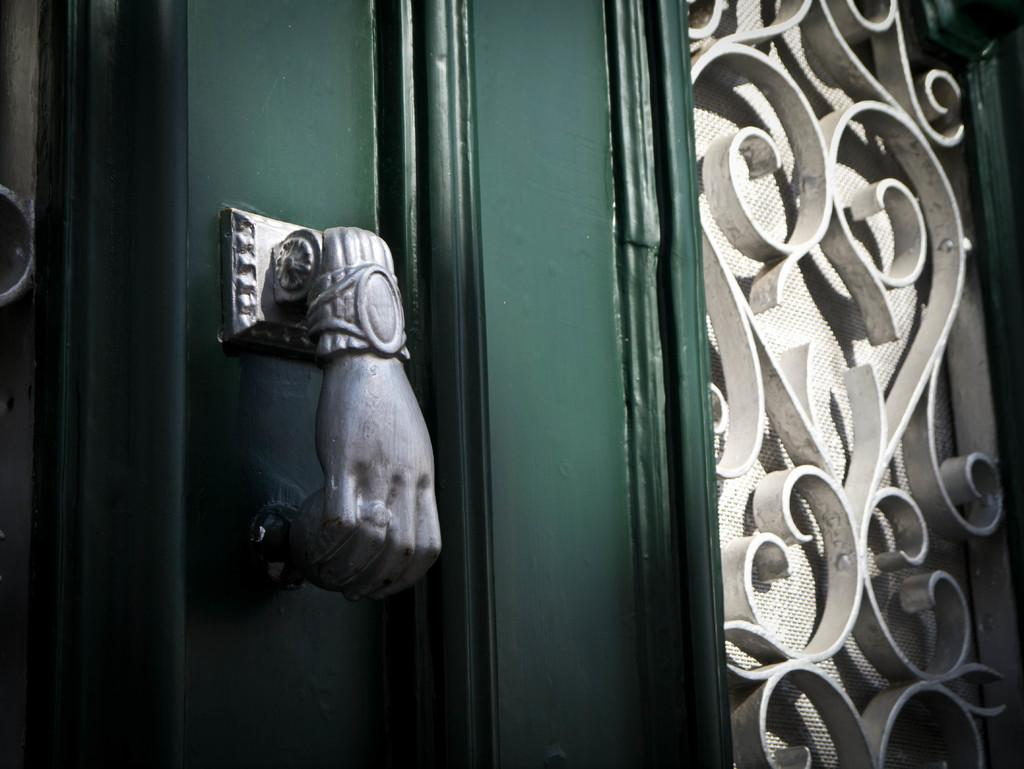What type of structure is present in the image? There is a door in the image. What feature does the door have? The door has a handle. Is there any other opening in the image besides the door? Yes, there is a window in the image. How many friends are standing next to the door in the image? There are no friends present in the image; it only features a door and a window. Can you see a flock of birds flying through the window in the image? There are no birds or flocks visible in the image; it only features a door and a window. 